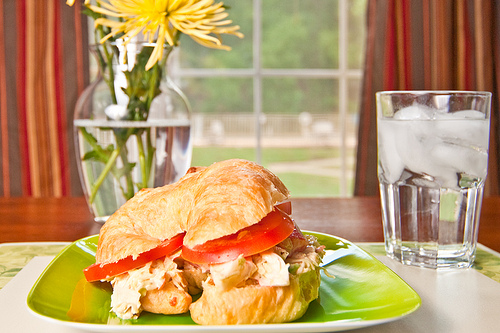Which part of the image is the green plate in, the bottom or the top? The green plate is located at the bottom part of the image. 